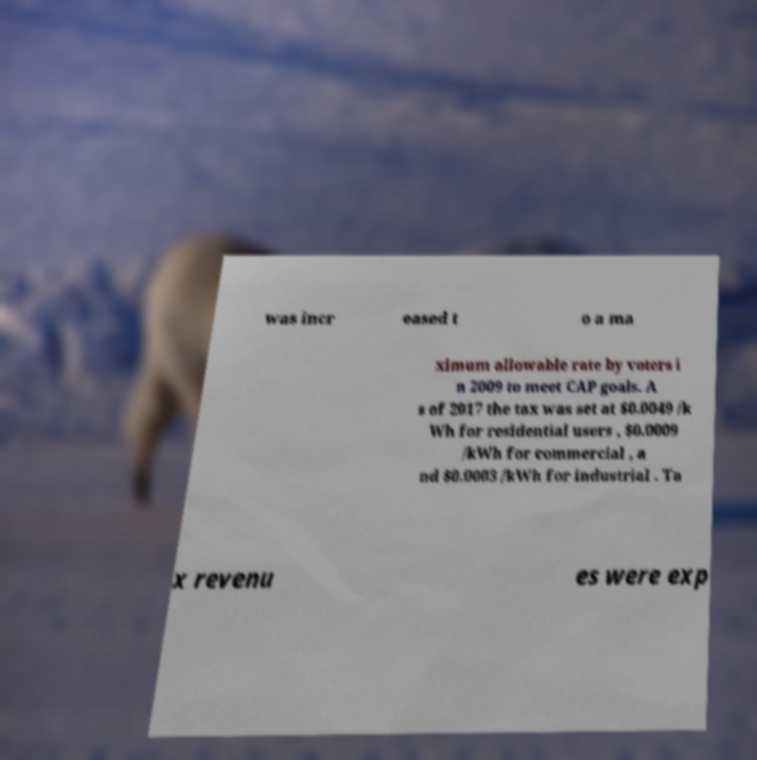What messages or text are displayed in this image? I need them in a readable, typed format. was incr eased t o a ma ximum allowable rate by voters i n 2009 to meet CAP goals. A s of 2017 the tax was set at $0.0049 /k Wh for residential users , $0.0009 /kWh for commercial , a nd $0.0003 /kWh for industrial . Ta x revenu es were exp 